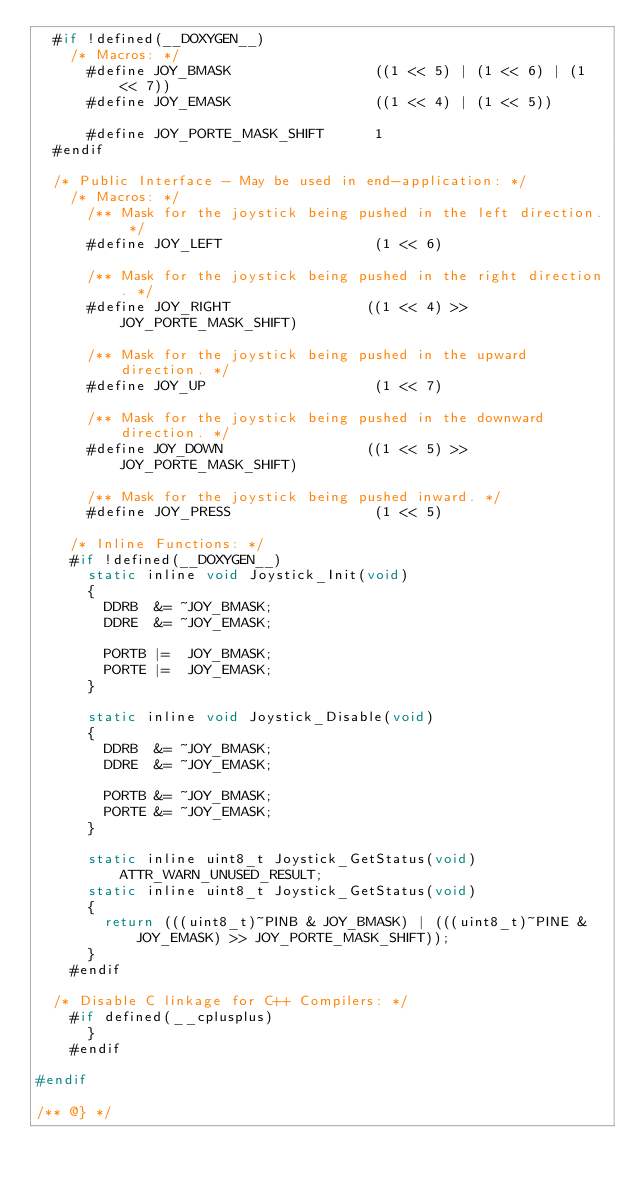Convert code to text. <code><loc_0><loc_0><loc_500><loc_500><_C_>	#if !defined(__DOXYGEN__)
		/* Macros: */
			#define JOY_BMASK                 ((1 << 5) | (1 << 6) | (1 << 7))
			#define JOY_EMASK                 ((1 << 4) | (1 << 5))

			#define JOY_PORTE_MASK_SHIFT      1
	#endif

	/* Public Interface - May be used in end-application: */
		/* Macros: */
			/** Mask for the joystick being pushed in the left direction. */
			#define JOY_LEFT                  (1 << 6)

			/** Mask for the joystick being pushed in the right direction. */
			#define JOY_RIGHT                ((1 << 4) >> JOY_PORTE_MASK_SHIFT)

			/** Mask for the joystick being pushed in the upward direction. */
			#define JOY_UP                    (1 << 7)

			/** Mask for the joystick being pushed in the downward direction. */
			#define JOY_DOWN                 ((1 << 5) >> JOY_PORTE_MASK_SHIFT)

			/** Mask for the joystick being pushed inward. */
			#define JOY_PRESS                 (1 << 5)

		/* Inline Functions: */
		#if !defined(__DOXYGEN__)
			static inline void Joystick_Init(void)
			{
				DDRB  &= ~JOY_BMASK;
				DDRE  &= ~JOY_EMASK;

				PORTB |=  JOY_BMASK;
				PORTE |=  JOY_EMASK;
			}

			static inline void Joystick_Disable(void)
			{
				DDRB  &= ~JOY_BMASK;
				DDRE  &= ~JOY_EMASK;

				PORTB &= ~JOY_BMASK;
				PORTE &= ~JOY_EMASK;
			}

			static inline uint8_t Joystick_GetStatus(void) ATTR_WARN_UNUSED_RESULT;
			static inline uint8_t Joystick_GetStatus(void)
			{
				return (((uint8_t)~PINB & JOY_BMASK) | (((uint8_t)~PINE & JOY_EMASK) >> JOY_PORTE_MASK_SHIFT));
			}
		#endif

	/* Disable C linkage for C++ Compilers: */
		#if defined(__cplusplus)
			}
		#endif

#endif

/** @} */

</code> 